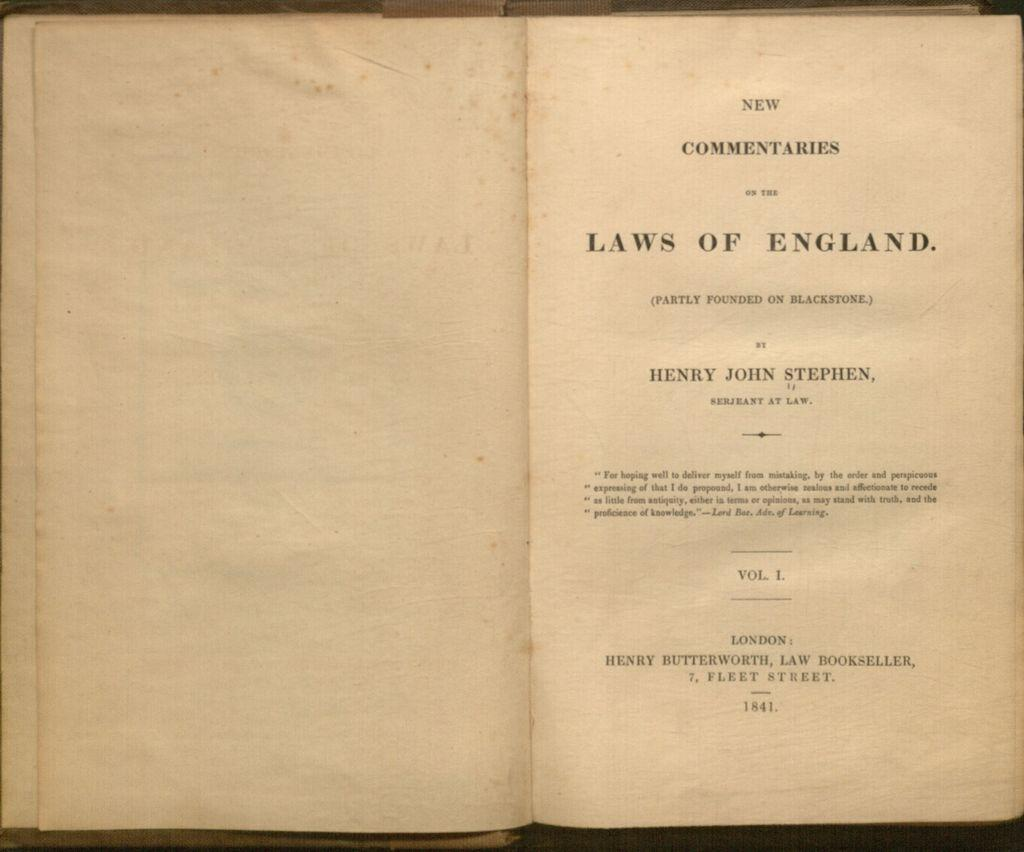Provide a one-sentence caption for the provided image. an old book open to the title page called Laws of England. 